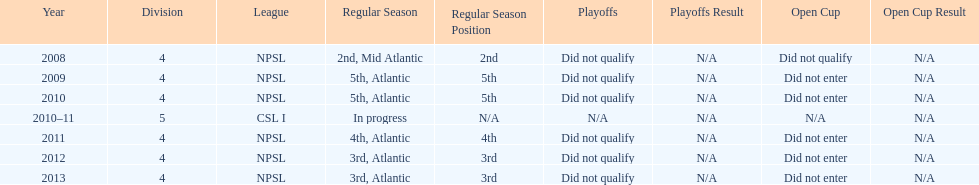What is the only year that is n/a? 2010-11. 